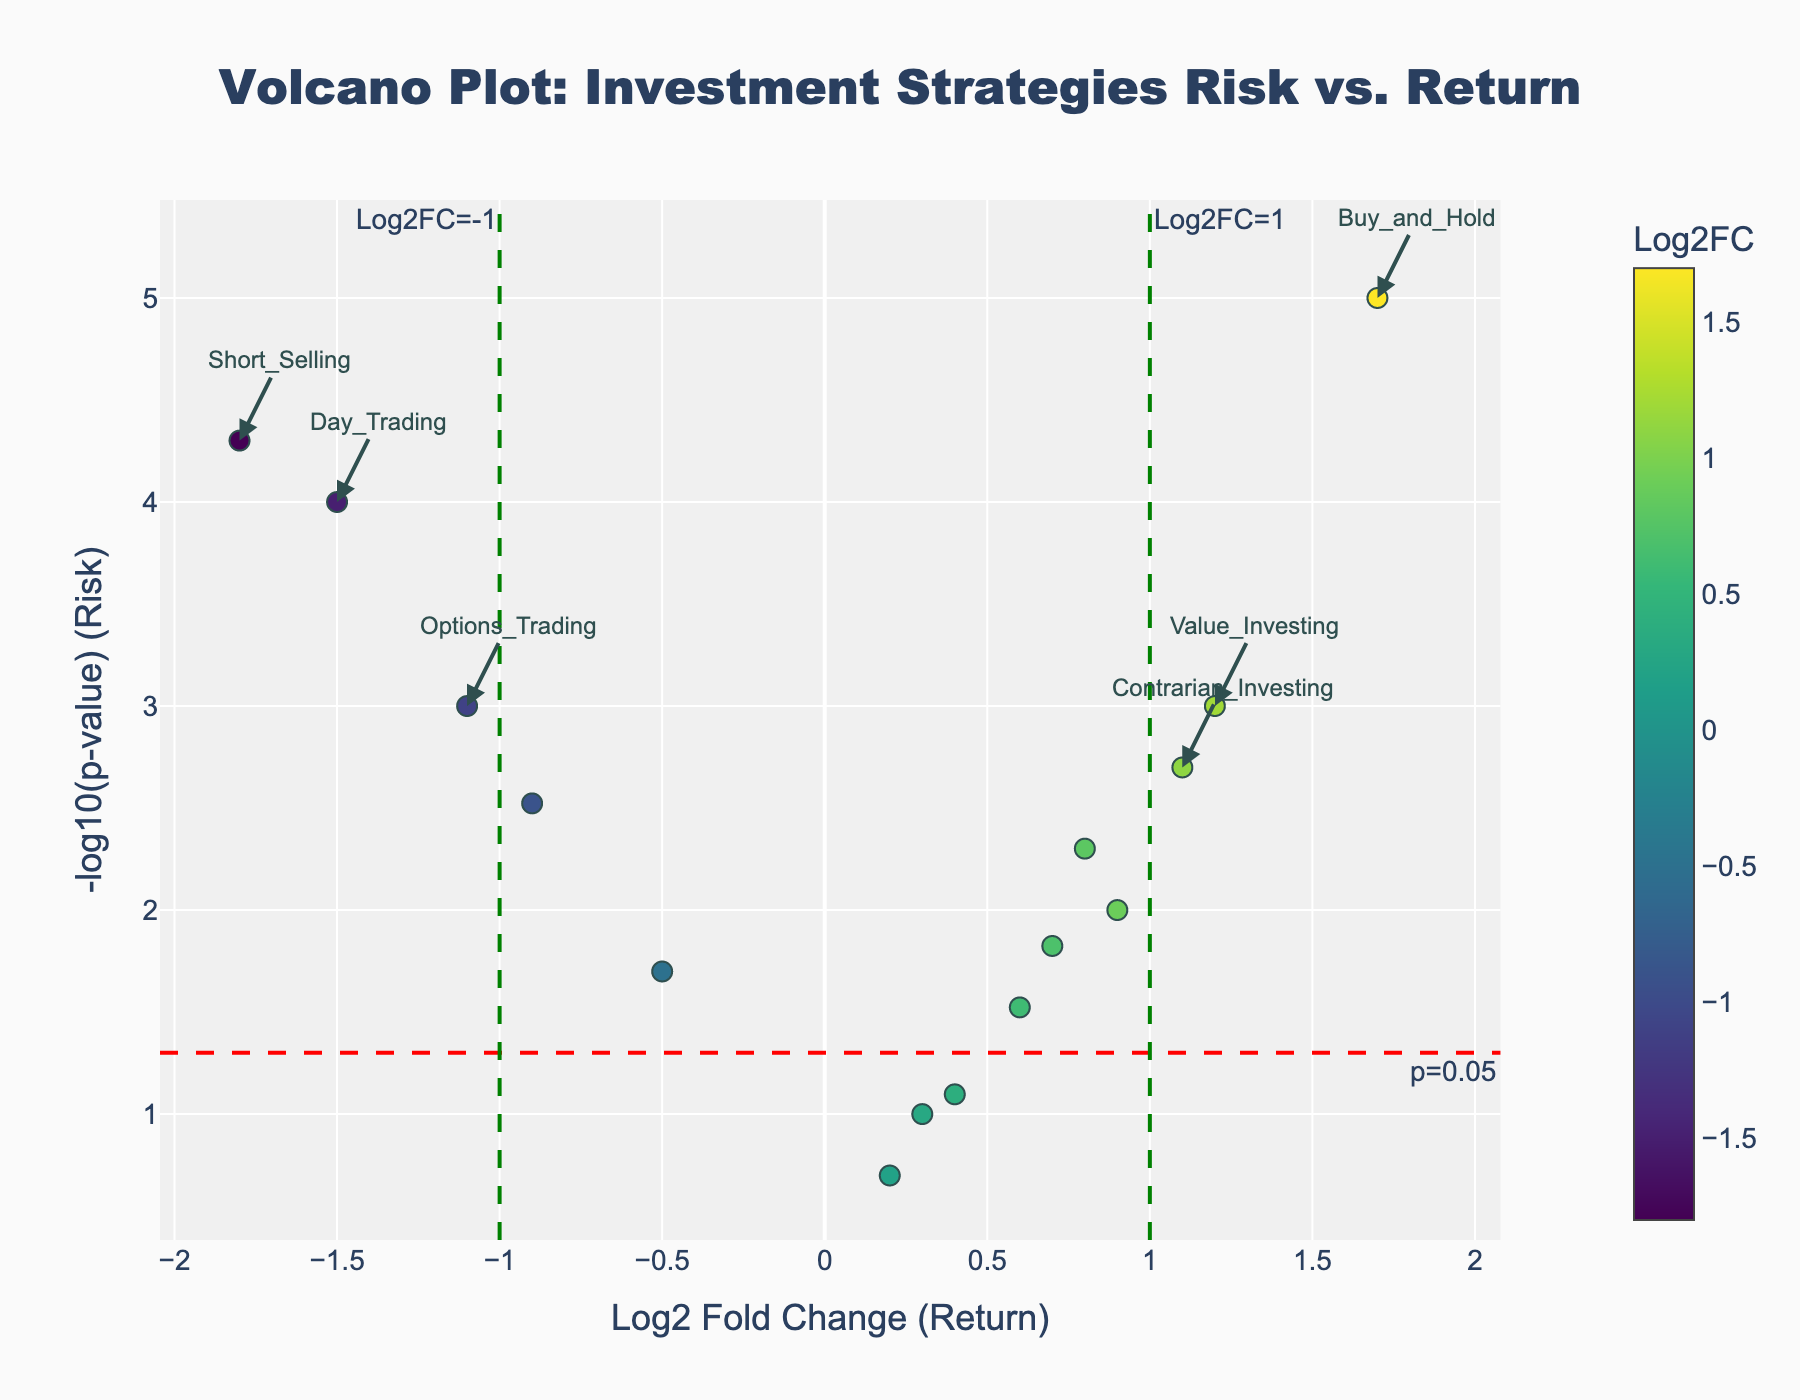What's the title of the volcano plot? The title is located at the top of the plot graph and is the largest text present. It reads: "Volcano Plot: Investment Strategies Risk vs. Return".
Answer: Volcano Plot: Investment Strategies Risk vs. Return How many investment strategies have a Log2 Fold Change greater than 1? Look for all points on the x-axis (Log2 Fold Change) that are to the right of the vertical line at Log2FC=1. This line is marked with a green dashed line. Counting the points gives us the answer.
Answer: 4 Which investment strategy has the highest Log2 Fold Change (Return)? Identify the point farthest to the right on the x-axis and check the annotation beside it, as extreme points are annotated. The corresponding strategy is "Buy_and_Hold".
Answer: Buy_and_Hold What is the Log2 Fold Change value for Short Selling? Identify the point labeled "Short_Selling" and look at its position along the x-axis to determine its Log2 Fold Change.
Answer: -1.8 Are there any strategies with a p-value greater than 0.1? Look at the y-axis representing -log10(p-value). A p-value of 0.1 corresponds to a y-axis value of -log10(0.1) = 1. Identify if any point is below y=1. Only "Arbitrage" is below this threshold.
Answer: Yes, Arbitrage How many strategies have a p-value less than or equal to 0.05? Identify all points above the horizontal line at y = -log10(0.05) (marked in red). Count these points.
Answer: 11 Which strategies have a negative Log2 Fold Change and a p-value less than 0.05? Look for points on the left of the vertical line at Log2FC=0 with a y-axis value greater than or equal to -log10(0.05). These values are marked with both red and green lines. The corresponding strategies are "Momentum_Trading", "Day_Trading", "Options_Trading", "Short_Selling", and "High_Frequency_Trading".
Answer: Momentum_Trading, Day_Trading, Options_Trading, Short_Selling, High_Frequency_Trading What is the meaning of the color gradient on the plot? The color gradient shown next to the color bar indicates the Log2 Fold Change values, with different colors representing the varying magnitudes of the Log2 Fold Change.
Answer: Indicates Log2FC values Is the strategy "Value_Investing" considered high risk based on its p-value? The p-value is indicated on the y-axis as -log10(p-value). If the point for "Value_Investing" is above the horizontal red line at -log10(0.05), its p-value ≤ 0.05, indicating higher statistical significance, but not necessarily high risk.
Answer: No 